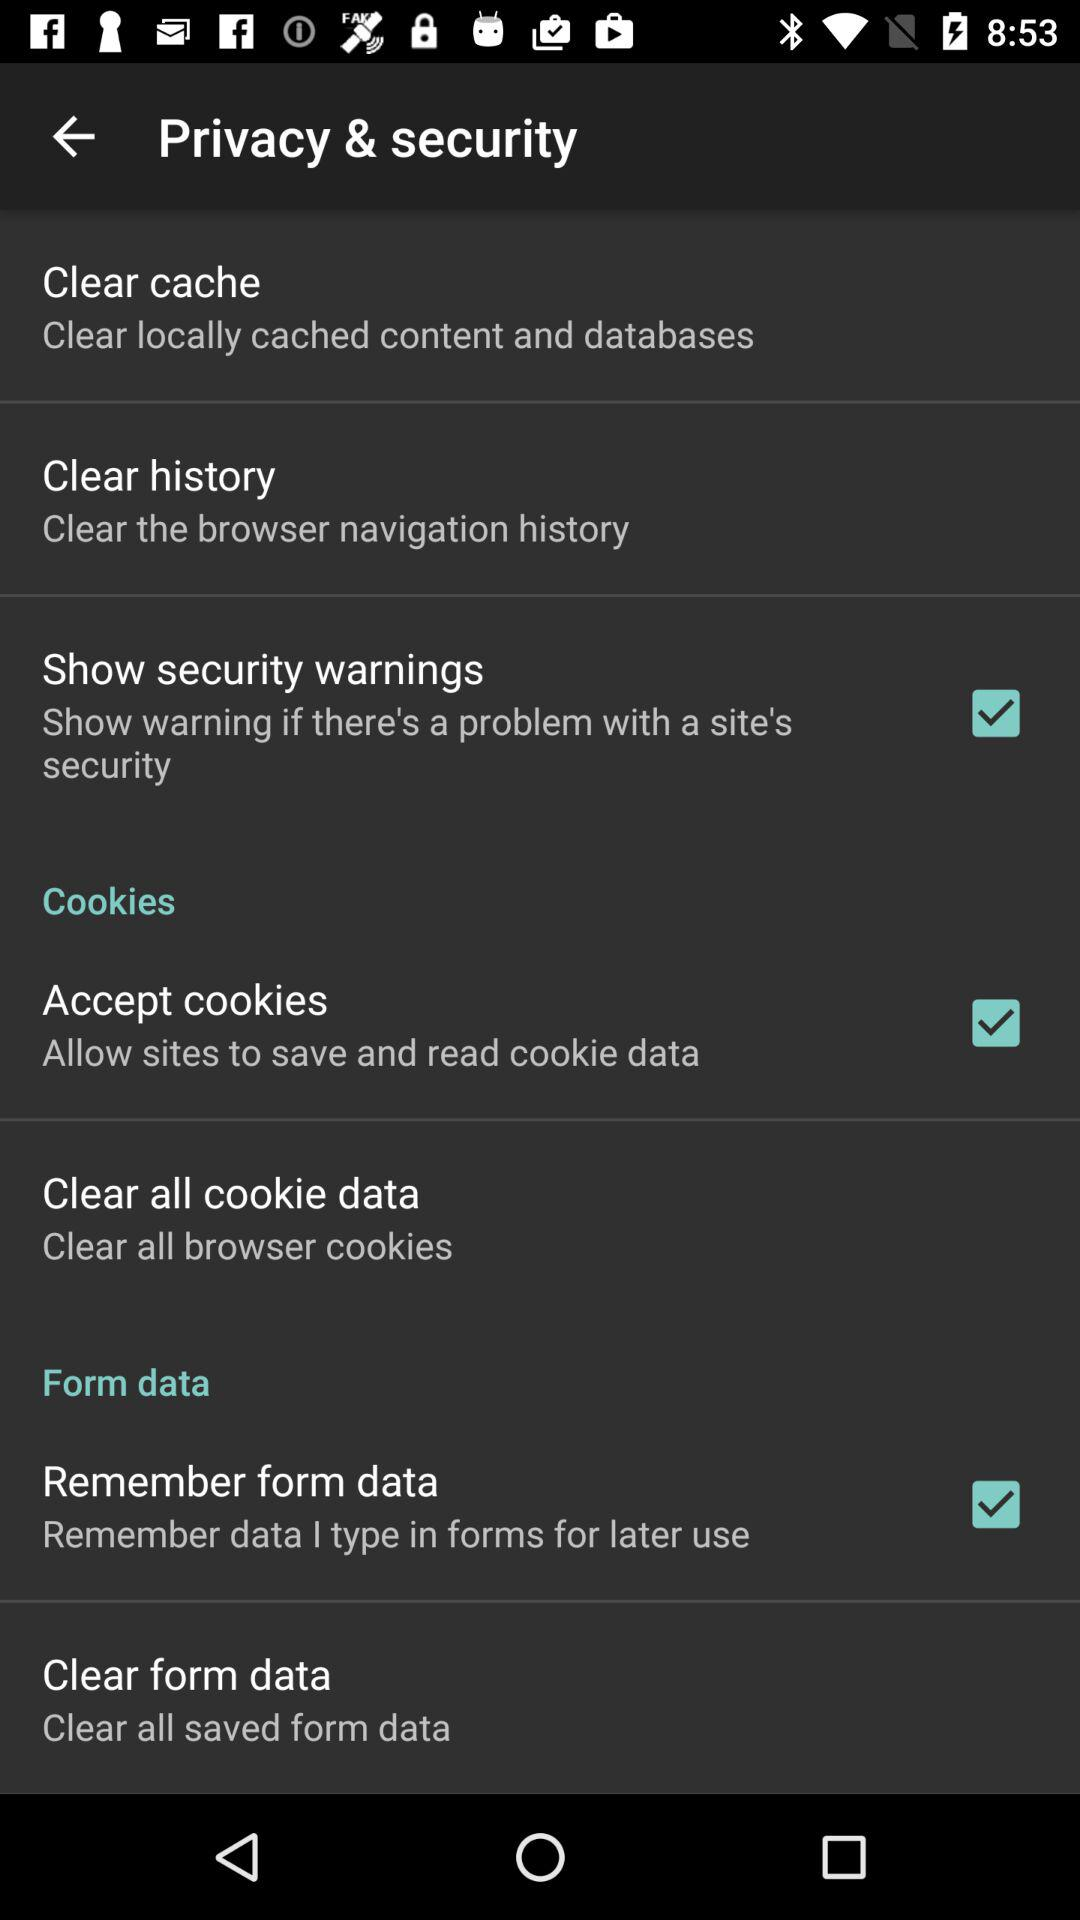What is the status of "Show security warnings"? The status of "Show security warnings" is "on". 